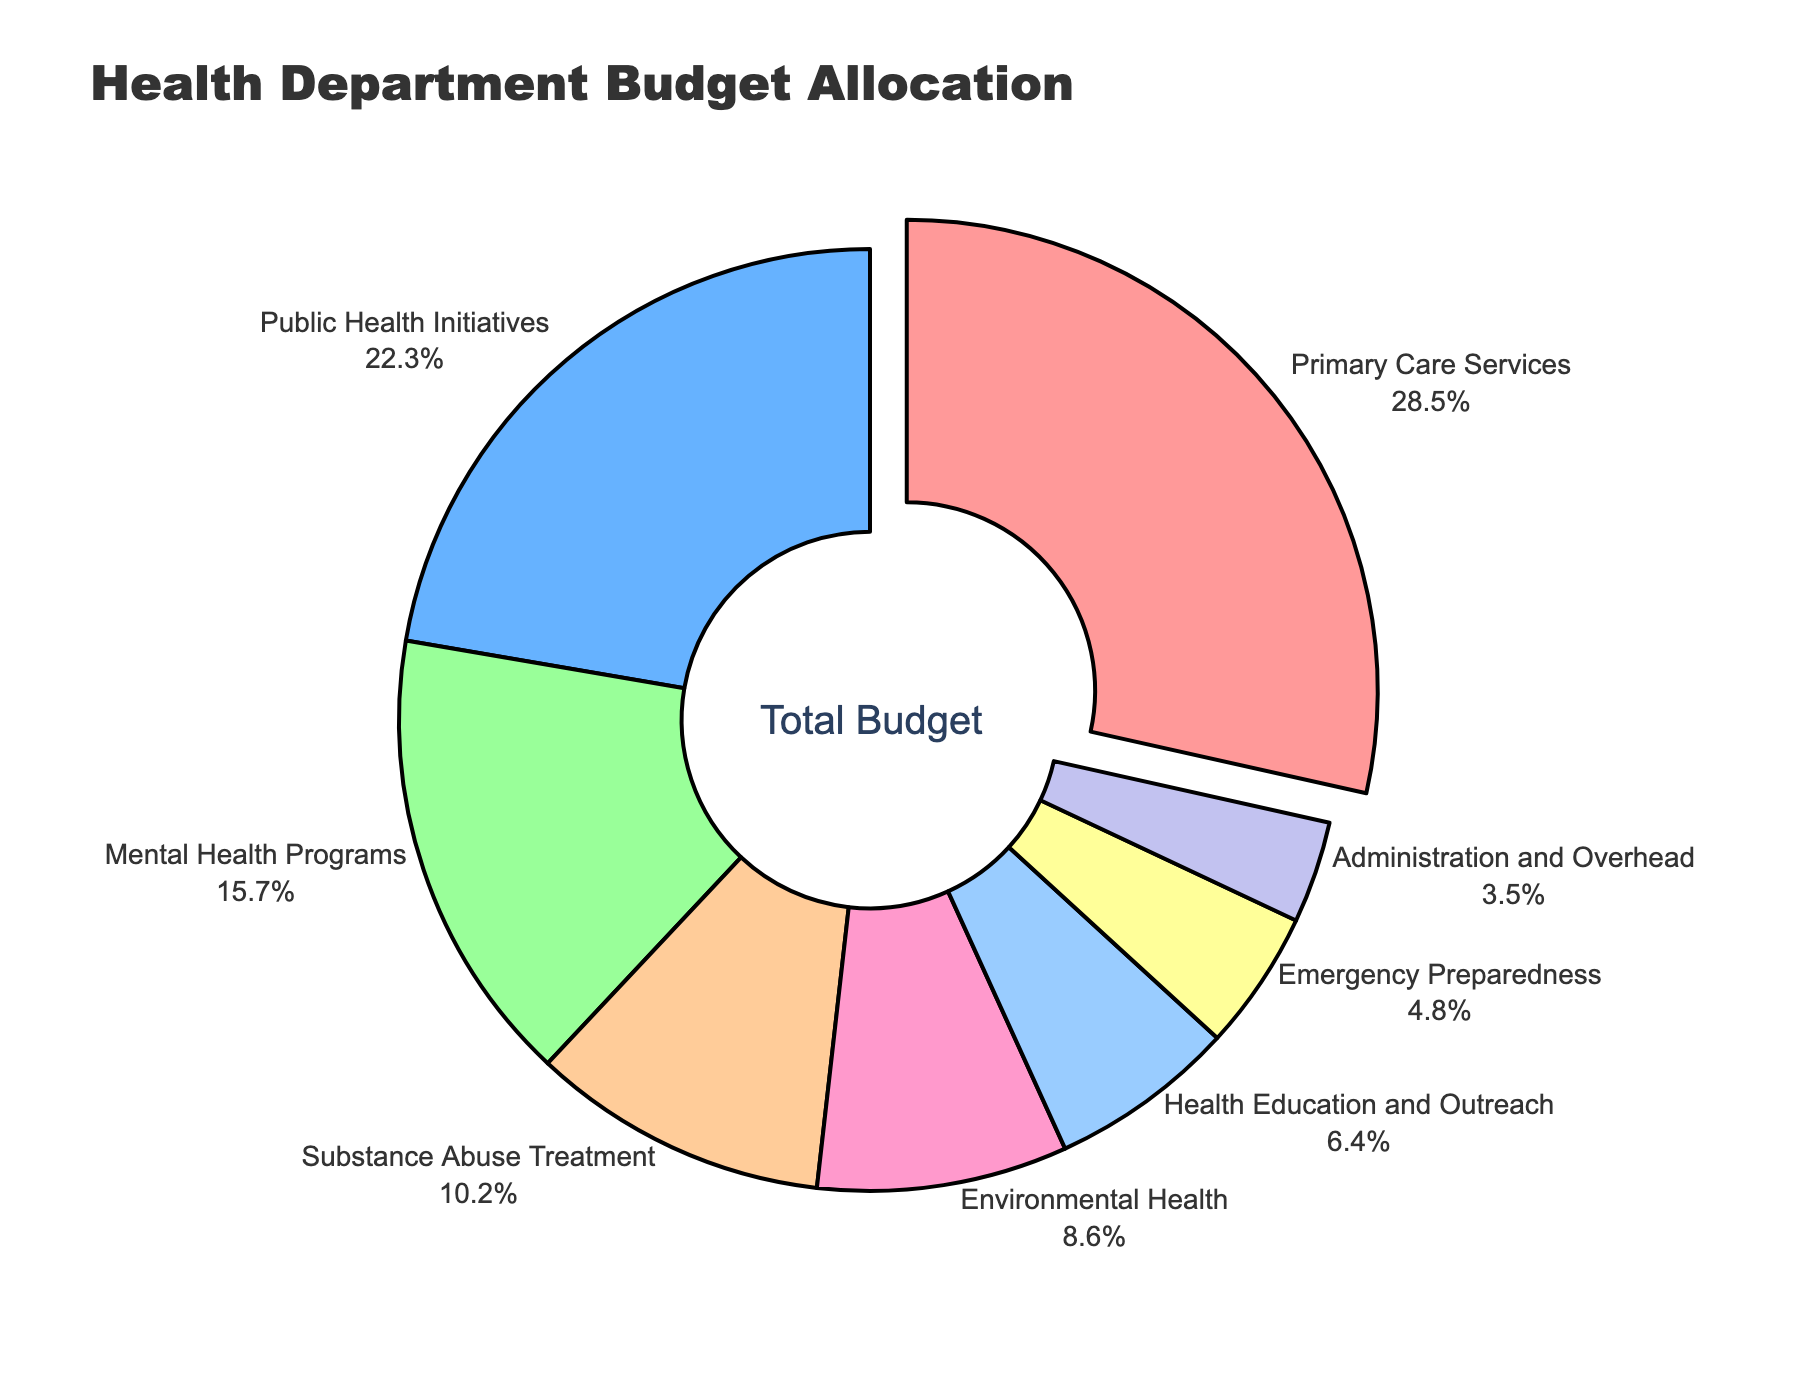What is the largest budget allocation? The pie chart reveals that the largest segment is pulled out slightly from the rest, labeled as "Primary Care Services" with a budget allocation of 28.5%.
Answer: Primary Care Services (28.5%) Which program has the smallest budget allocation? The smallest segment in the pie chart is labeled "Administration and Overhead" with a budget allocation of 3.5%.
Answer: Administration and Overhead (3.5%) Which programs have a budget allocation greater than 20%? By visually inspecting the pie chart, the segments labeled "Primary Care Services" (28.5%) and "Public Health Initiatives" (22.3%) have budget allocations greater than 20%.
Answer: Primary Care Services, Public Health Initiatives How much larger is the budget for Primary Care Services compared to Mental Health Programs? The budget for Primary Care Services is 28.5% and for Mental Health Programs is 15.7%. The difference can be calculated as 28.5% - 15.7% = 12.8%.
Answer: 12.8% What is the combined budget allocation for Substance Abuse Treatment and Environmental Health? The pie chart shows Substance Abuse Treatment with 10.2% and Environmental Health with 8.6%. The combined allocation is 10.2% + 8.6% = 18.8%.
Answer: 18.8% How does the budget allocation for Health Education and Outreach compare to Emergency Preparedness? Health Education and Outreach has a budget allocation of 6.4% while Emergency Preparedness has 4.8%. By comparing these, 6.4% is greater than 4.8%.
Answer: Health Education and Outreach > Emergency Preparedness Which sector's allocation is visually represented with a pink color? By identifying the pink color in the pie chart, it corresponds to the segment labeled "Primary Care Services."
Answer: Primary Care Services What is the average budget allocation across all programs? Sum of all budget allocations: 28.5% + 22.3% + 15.7% + 10.2% + 8.6% + 6.4% + 4.8% + 3.5% = 100%. Since there are 8 programs, the average is 100% / 8 = 12.5%.
Answer: 12.5% If we combined the allocations for Public Health Initiatives and Emergency Preparedness, how would it compare to the allocation for Primary Care Services? Public Health Initiatives have 22.3% and Emergency Preparedness has 4.8%. Combined, they make 22.3% + 4.8% = 27.1%, which is compared to Primary Care Services' 28.5%. Thus, 27.1% is slightly less than 28.5%.
Answer: 27.1% < 28.5% 